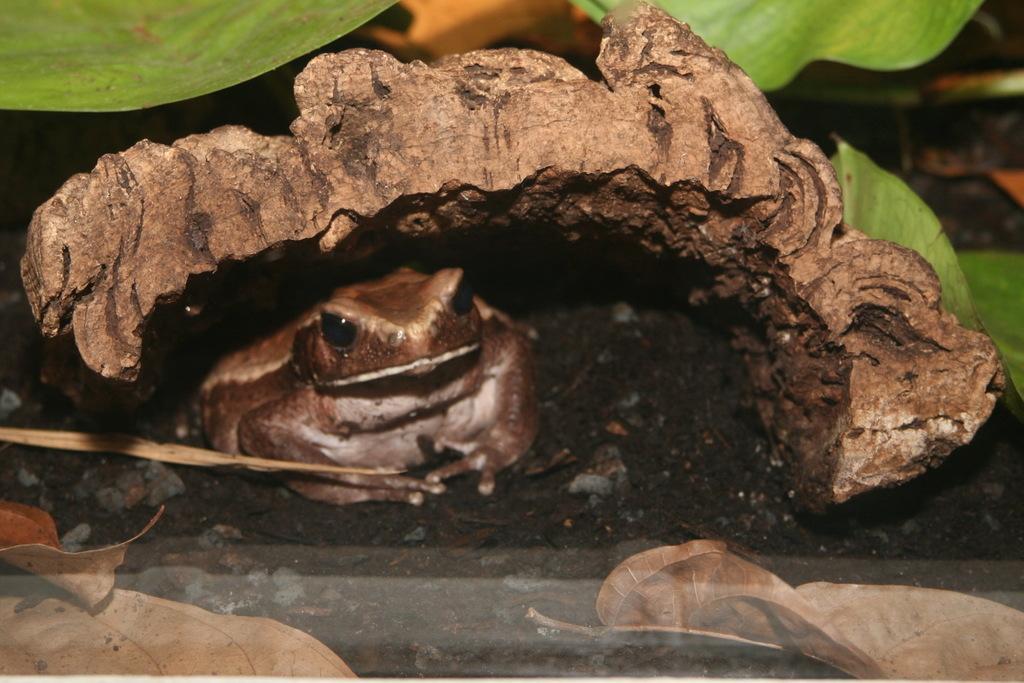Can you describe this image briefly? In the picture we can see a frog which is sitting under some leaves and the frog is brown in color and near it we can see some dried leaves on the path. 